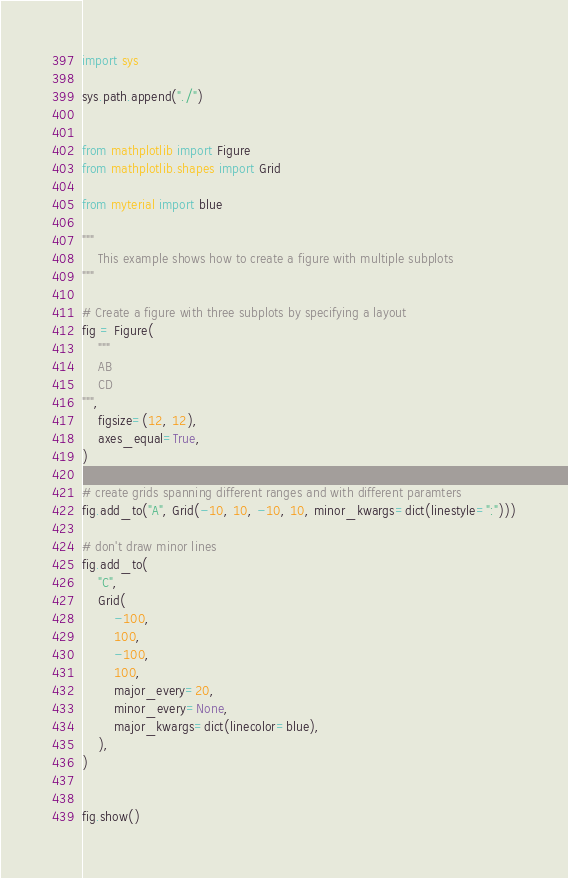<code> <loc_0><loc_0><loc_500><loc_500><_Python_>import sys

sys.path.append("./")


from mathplotlib import Figure
from mathplotlib.shapes import Grid

from myterial import blue

"""
    This example shows how to create a figure with multiple subplots
"""

# Create a figure with three subplots by specifying a layout
fig = Figure(
    """
    AB
    CD
""",
    figsize=(12, 12),
    axes_equal=True,
)

# create grids spanning different ranges and with different paramters
fig.add_to("A", Grid(-10, 10, -10, 10, minor_kwargs=dict(linestyle=":")))

# don't draw minor lines
fig.add_to(
    "C",
    Grid(
        -100,
        100,
        -100,
        100,
        major_every=20,
        minor_every=None,
        major_kwargs=dict(linecolor=blue),
    ),
)


fig.show()
</code> 